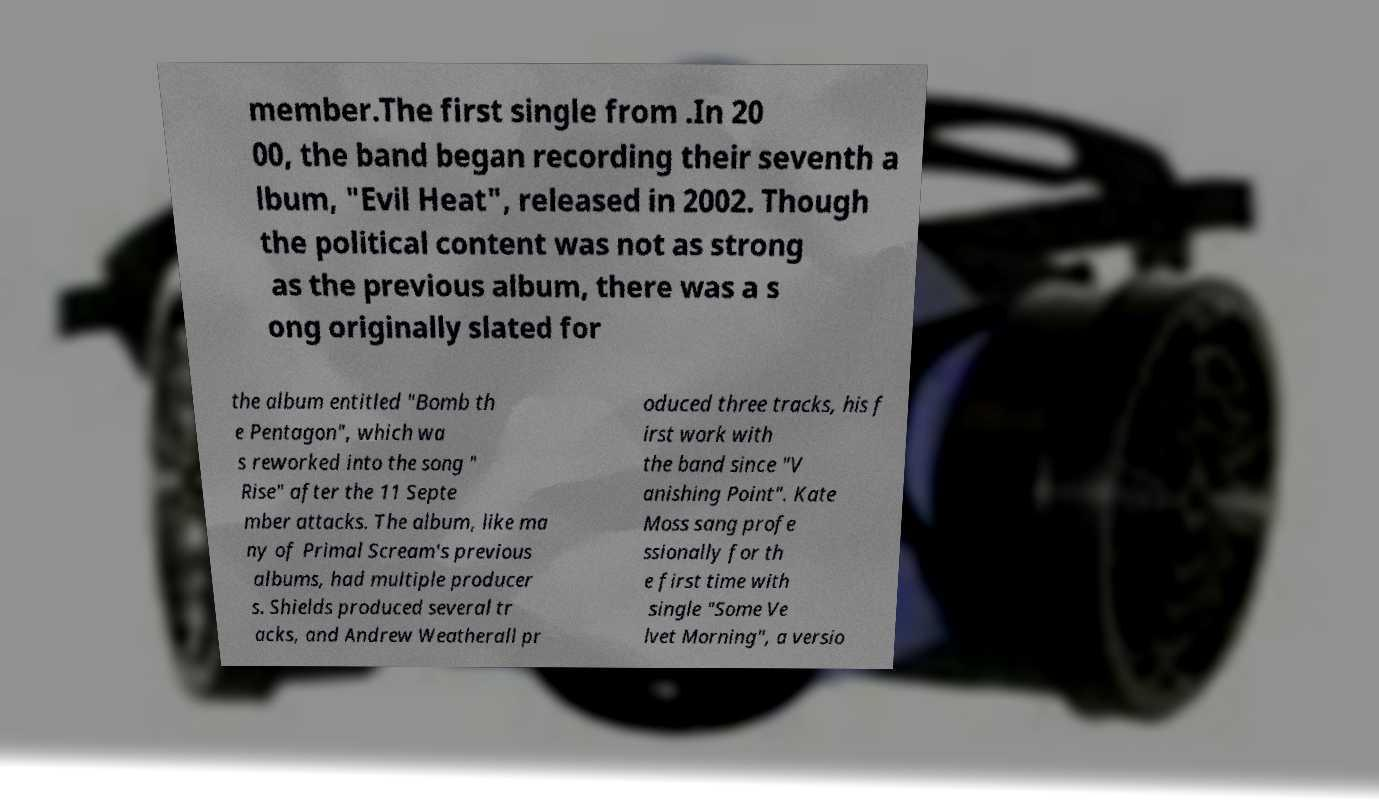Could you extract and type out the text from this image? member.The first single from .In 20 00, the band began recording their seventh a lbum, "Evil Heat", released in 2002. Though the political content was not as strong as the previous album, there was a s ong originally slated for the album entitled "Bomb th e Pentagon", which wa s reworked into the song " Rise" after the 11 Septe mber attacks. The album, like ma ny of Primal Scream's previous albums, had multiple producer s. Shields produced several tr acks, and Andrew Weatherall pr oduced three tracks, his f irst work with the band since "V anishing Point". Kate Moss sang profe ssionally for th e first time with single "Some Ve lvet Morning", a versio 